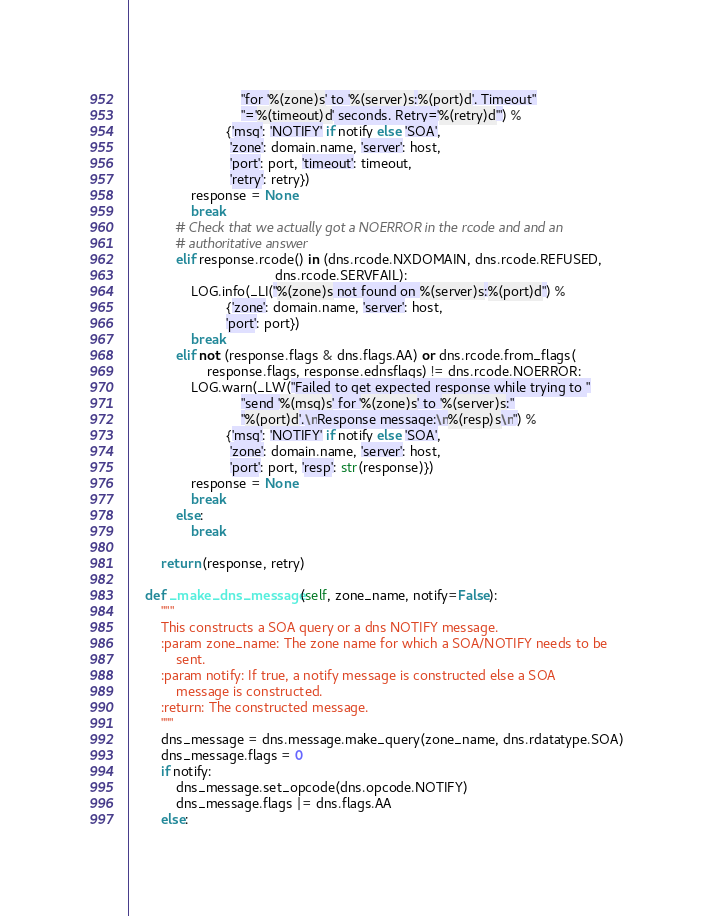Convert code to text. <code><loc_0><loc_0><loc_500><loc_500><_Python_>                             "for '%(zone)s' to '%(server)s:%(port)d'. Timeout"
                             "='%(timeout)d' seconds. Retry='%(retry)d'") %
                         {'msg': 'NOTIFY' if notify else 'SOA',
                          'zone': domain.name, 'server': host,
                          'port': port, 'timeout': timeout,
                          'retry': retry})
                response = None
                break
            # Check that we actually got a NOERROR in the rcode and and an
            # authoritative answer
            elif response.rcode() in (dns.rcode.NXDOMAIN, dns.rcode.REFUSED,
                                      dns.rcode.SERVFAIL):
                LOG.info(_LI("%(zone)s not found on %(server)s:%(port)d") %
                         {'zone': domain.name, 'server': host,
                         'port': port})
                break
            elif not (response.flags & dns.flags.AA) or dns.rcode.from_flags(
                    response.flags, response.ednsflags) != dns.rcode.NOERROR:
                LOG.warn(_LW("Failed to get expected response while trying to "
                             "send '%(msg)s' for '%(zone)s' to '%(server)s:"
                             "%(port)d'.\nResponse message:\n%(resp)s\n") %
                         {'msg': 'NOTIFY' if notify else 'SOA',
                          'zone': domain.name, 'server': host,
                          'port': port, 'resp': str(response)})
                response = None
                break
            else:
                break

        return (response, retry)

    def _make_dns_message(self, zone_name, notify=False):
        """
        This constructs a SOA query or a dns NOTIFY message.
        :param zone_name: The zone name for which a SOA/NOTIFY needs to be
            sent.
        :param notify: If true, a notify message is constructed else a SOA
            message is constructed.
        :return: The constructed message.
        """
        dns_message = dns.message.make_query(zone_name, dns.rdatatype.SOA)
        dns_message.flags = 0
        if notify:
            dns_message.set_opcode(dns.opcode.NOTIFY)
            dns_message.flags |= dns.flags.AA
        else:</code> 